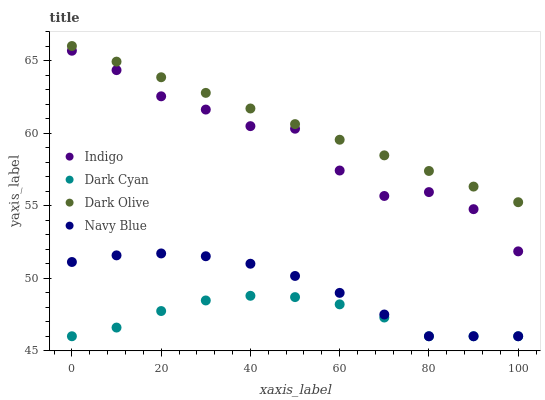Does Dark Cyan have the minimum area under the curve?
Answer yes or no. Yes. Does Dark Olive have the maximum area under the curve?
Answer yes or no. Yes. Does Navy Blue have the minimum area under the curve?
Answer yes or no. No. Does Navy Blue have the maximum area under the curve?
Answer yes or no. No. Is Dark Olive the smoothest?
Answer yes or no. Yes. Is Indigo the roughest?
Answer yes or no. Yes. Is Navy Blue the smoothest?
Answer yes or no. No. Is Navy Blue the roughest?
Answer yes or no. No. Does Dark Cyan have the lowest value?
Answer yes or no. Yes. Does Dark Olive have the lowest value?
Answer yes or no. No. Does Dark Olive have the highest value?
Answer yes or no. Yes. Does Navy Blue have the highest value?
Answer yes or no. No. Is Dark Cyan less than Dark Olive?
Answer yes or no. Yes. Is Dark Olive greater than Dark Cyan?
Answer yes or no. Yes. Does Navy Blue intersect Dark Cyan?
Answer yes or no. Yes. Is Navy Blue less than Dark Cyan?
Answer yes or no. No. Is Navy Blue greater than Dark Cyan?
Answer yes or no. No. Does Dark Cyan intersect Dark Olive?
Answer yes or no. No. 